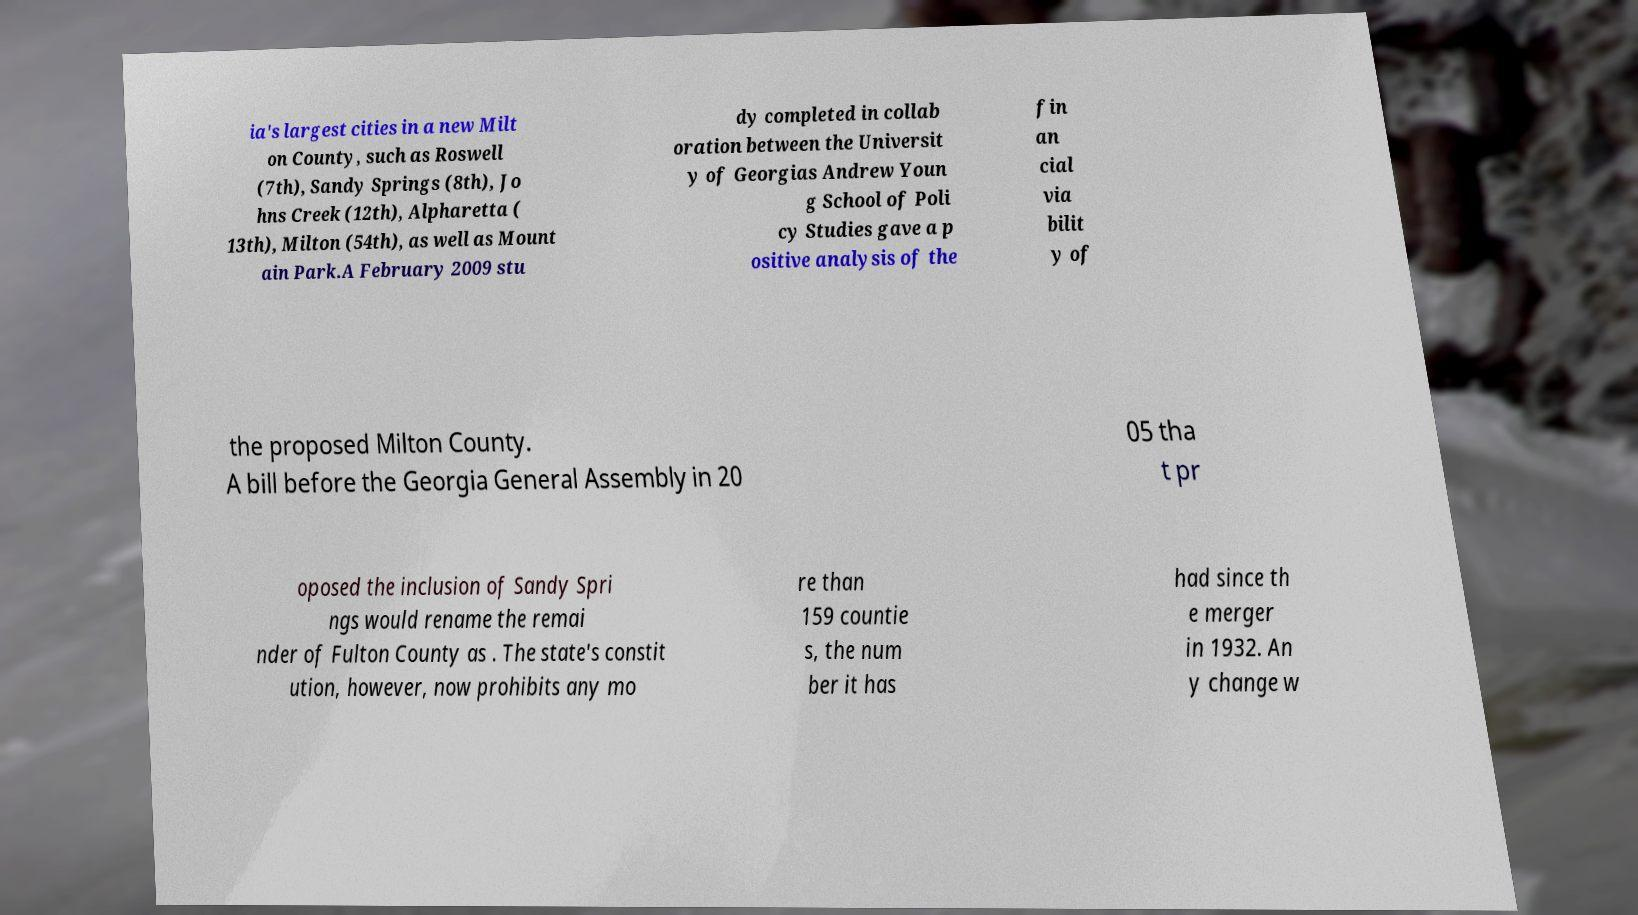Can you accurately transcribe the text from the provided image for me? ia's largest cities in a new Milt on County, such as Roswell (7th), Sandy Springs (8th), Jo hns Creek (12th), Alpharetta ( 13th), Milton (54th), as well as Mount ain Park.A February 2009 stu dy completed in collab oration between the Universit y of Georgias Andrew Youn g School of Poli cy Studies gave a p ositive analysis of the fin an cial via bilit y of the proposed Milton County. A bill before the Georgia General Assembly in 20 05 tha t pr oposed the inclusion of Sandy Spri ngs would rename the remai nder of Fulton County as . The state's constit ution, however, now prohibits any mo re than 159 countie s, the num ber it has had since th e merger in 1932. An y change w 